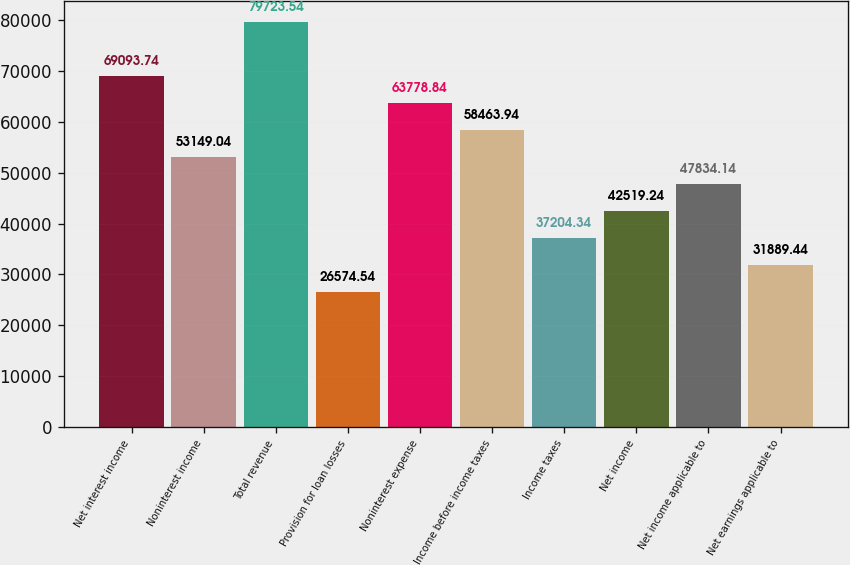Convert chart to OTSL. <chart><loc_0><loc_0><loc_500><loc_500><bar_chart><fcel>Net interest income<fcel>Noninterest income<fcel>Total revenue<fcel>Provision for loan losses<fcel>Noninterest expense<fcel>Income before income taxes<fcel>Income taxes<fcel>Net income<fcel>Net income applicable to<fcel>Net earnings applicable to<nl><fcel>69093.7<fcel>53149<fcel>79723.5<fcel>26574.5<fcel>63778.8<fcel>58463.9<fcel>37204.3<fcel>42519.2<fcel>47834.1<fcel>31889.4<nl></chart> 